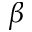Convert formula to latex. <formula><loc_0><loc_0><loc_500><loc_500>\beta</formula> 